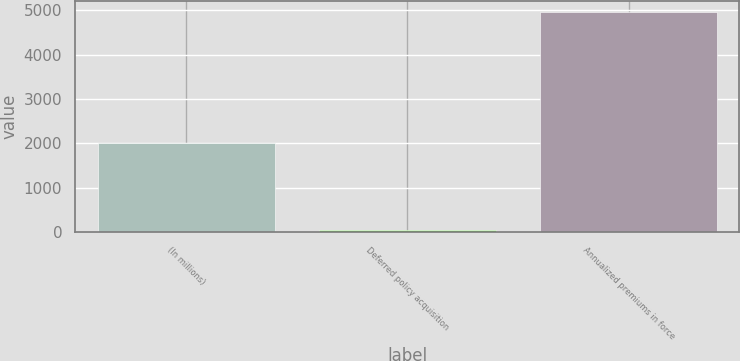Convert chart to OTSL. <chart><loc_0><loc_0><loc_500><loc_500><bar_chart><fcel>(In millions)<fcel>Deferred policy acquisition<fcel>Annualized premiums in force<nl><fcel>2009<fcel>54.2<fcel>4956<nl></chart> 